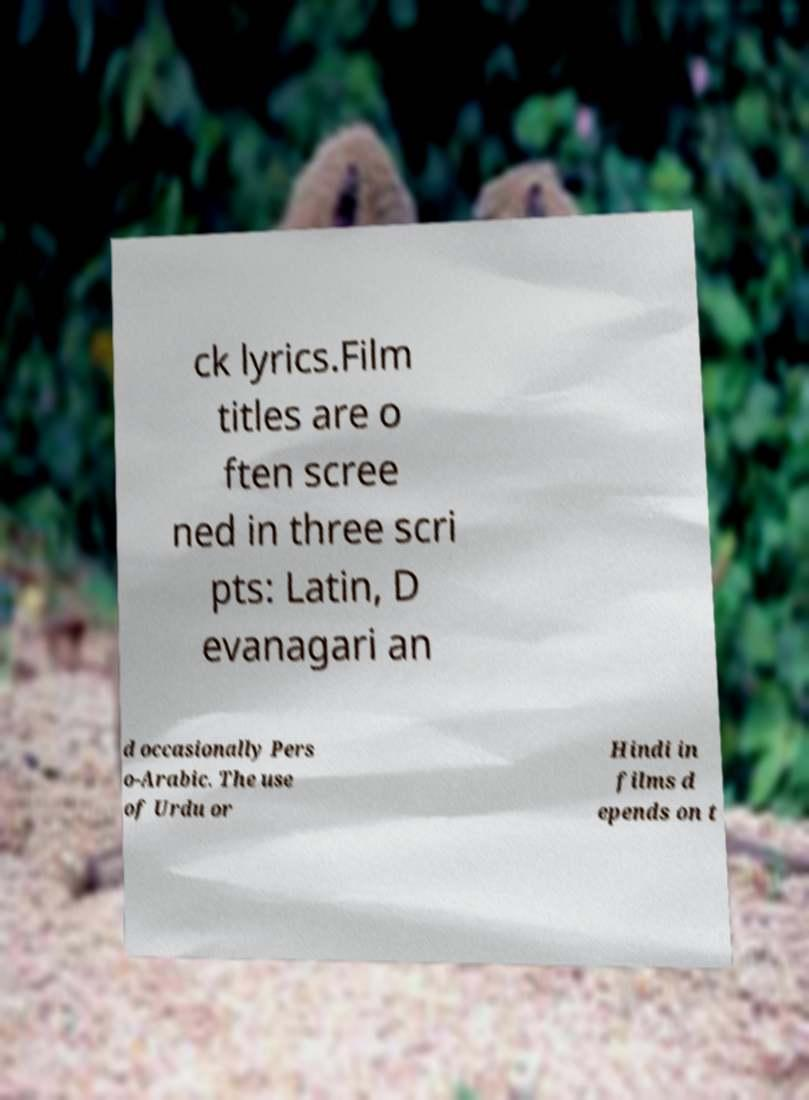For documentation purposes, I need the text within this image transcribed. Could you provide that? ck lyrics.Film titles are o ften scree ned in three scri pts: Latin, D evanagari an d occasionally Pers o-Arabic. The use of Urdu or Hindi in films d epends on t 